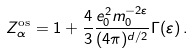Convert formula to latex. <formula><loc_0><loc_0><loc_500><loc_500>Z _ { \alpha } ^ { \text {os} } = 1 + \frac { 4 } { 3 } \frac { e _ { 0 } ^ { 2 } m _ { 0 } ^ { - 2 \varepsilon } } { ( 4 \pi ) ^ { d / 2 } } \Gamma ( \varepsilon ) \, .</formula> 